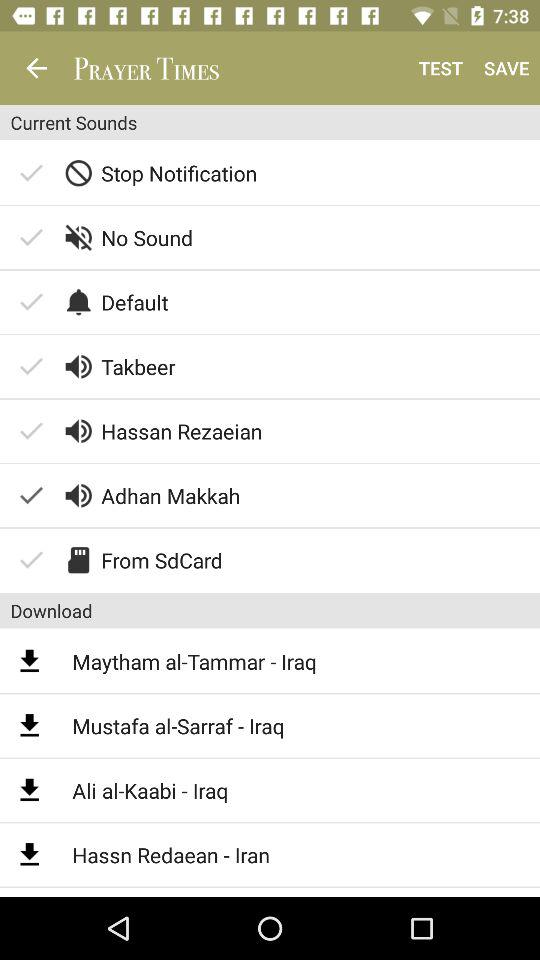What are the titles of some downloaded audio? The titles of some downloaded audio are: "Maytham al-Tammar - Iraq", "Mustafa al-Sarraf - Iraq", "Ali al-Kaabi - Iraq", and "Hassn Redaean - Iran". 